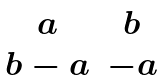<formula> <loc_0><loc_0><loc_500><loc_500>\begin{matrix} a & b \\ b - a & - a \end{matrix}</formula> 